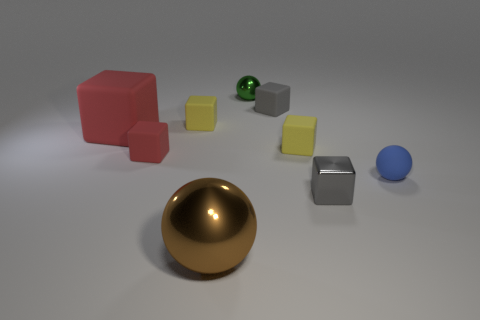Subtract all blue spheres. How many spheres are left? 2 Subtract all brown balls. How many yellow blocks are left? 2 Subtract all gray cubes. How many cubes are left? 4 Add 1 rubber cubes. How many objects exist? 10 Subtract 2 spheres. How many spheres are left? 1 Subtract all balls. How many objects are left? 6 Subtract all brown balls. Subtract all brown blocks. How many balls are left? 2 Subtract all metallic balls. Subtract all tiny shiny spheres. How many objects are left? 6 Add 1 tiny rubber things. How many tiny rubber things are left? 6 Add 3 tiny gray metallic blocks. How many tiny gray metallic blocks exist? 4 